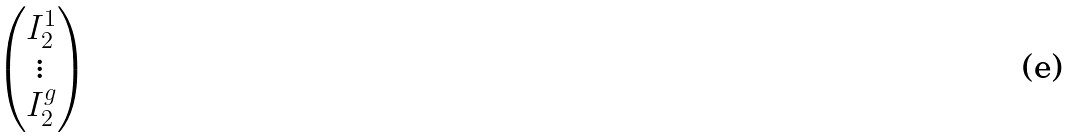Convert formula to latex. <formula><loc_0><loc_0><loc_500><loc_500>\begin{pmatrix} I _ { 2 } ^ { 1 } \\ \vdots \\ I _ { 2 } ^ { g } \end{pmatrix}</formula> 